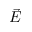<formula> <loc_0><loc_0><loc_500><loc_500>\ V e c { E }</formula> 